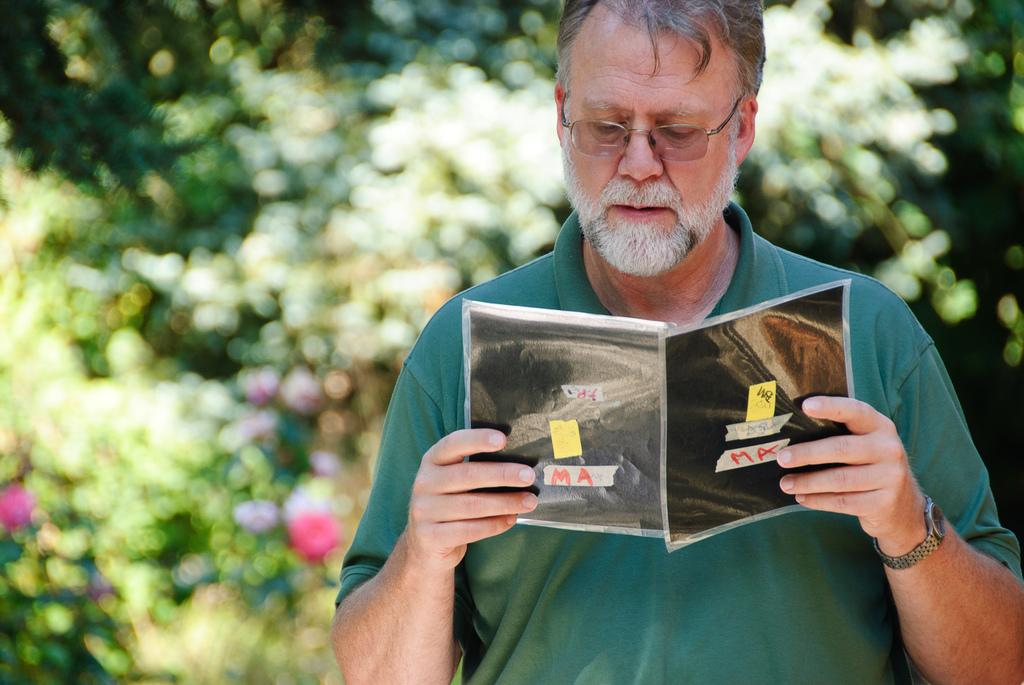What is the main subject of the image? There is a person in the image. What is the person holding in the image? The person is holding a book. Can you describe the background of the image? The background of the image is blurry. How long does the kiss between the person and the beast last in the image? There is no kiss or beast present in the image. 